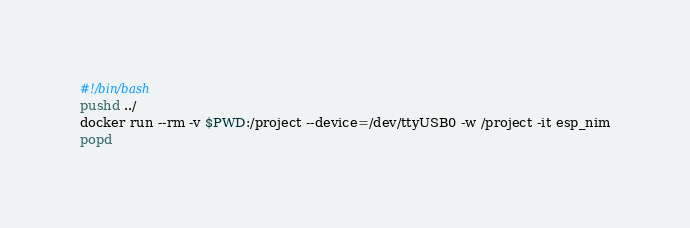Convert code to text. <code><loc_0><loc_0><loc_500><loc_500><_Bash_>#!/bin/bash
pushd ../
docker run --rm -v $PWD:/project --device=/dev/ttyUSB0 -w /project -it esp_nim
popd</code> 